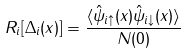<formula> <loc_0><loc_0><loc_500><loc_500>R _ { i } [ \Delta _ { i } ( { x } ) ] = \frac { \langle { \hat { \psi } } _ { i \uparrow } ( { x } ) { \hat { \psi } } _ { i \downarrow } ( { x } ) \rangle } { N ( 0 ) }</formula> 